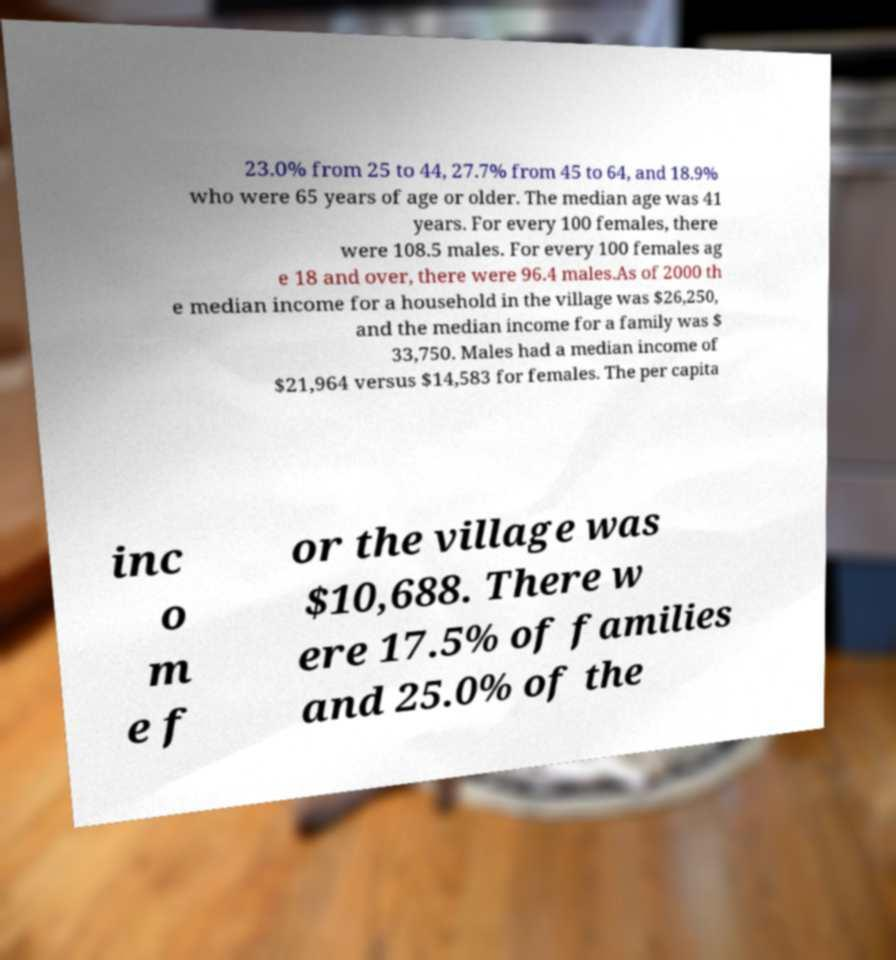There's text embedded in this image that I need extracted. Can you transcribe it verbatim? 23.0% from 25 to 44, 27.7% from 45 to 64, and 18.9% who were 65 years of age or older. The median age was 41 years. For every 100 females, there were 108.5 males. For every 100 females ag e 18 and over, there were 96.4 males.As of 2000 th e median income for a household in the village was $26,250, and the median income for a family was $ 33,750. Males had a median income of $21,964 versus $14,583 for females. The per capita inc o m e f or the village was $10,688. There w ere 17.5% of families and 25.0% of the 